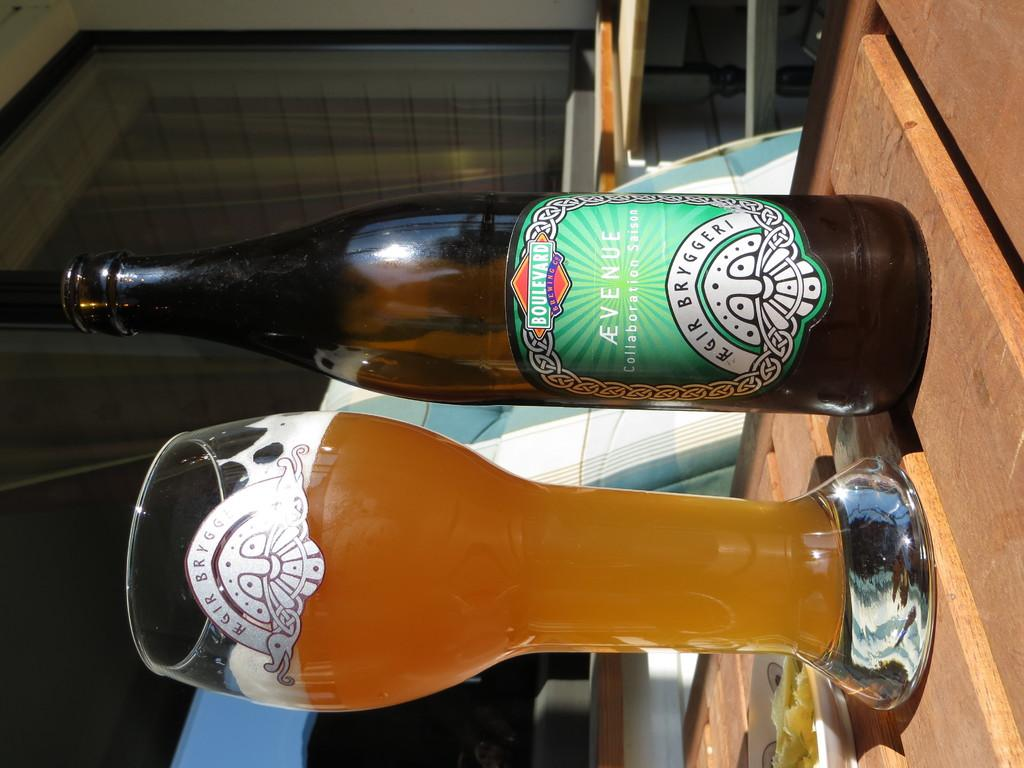<image>
Present a compact description of the photo's key features. A green can has the logo AE Venue on it. 